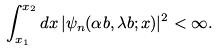Convert formula to latex. <formula><loc_0><loc_0><loc_500><loc_500>\int _ { x _ { 1 } } ^ { x _ { 2 } } d x \, | \psi _ { n } ( \alpha b , \lambda b ; x ) | ^ { 2 } < \infty .</formula> 